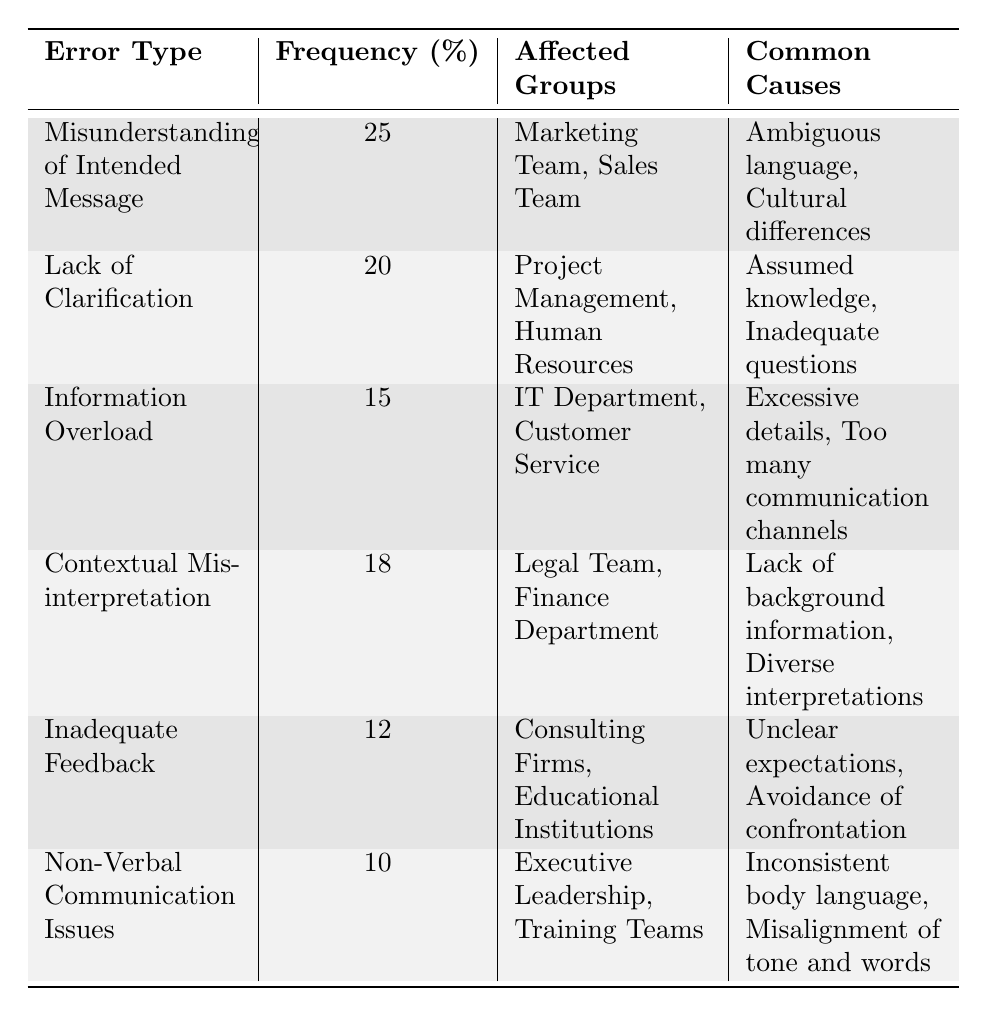What is the most common type of communication error? The table shows that the "Misunderstanding of Intended Message" has the highest frequency percentage at 25%.
Answer: Misunderstanding of Intended Message Which group is most affected by "Information Overload"? The table indicates that both the "IT Department" and "Customer Service" are affected by "Information Overload," but it does not specify which is more affected. Both teams are listed under the same error type.
Answer: IT Department and Customer Service What percentage of communication errors are categorized as "Inadequate Feedback"? The table provides a frequency percentage of 12% for "Inadequate Feedback."
Answer: 12% How many groups are affected by "Lack of Clarification"? The table lists "Project Management" and "Human Resources" as the two affected groups, indicating that there are two groups in total.
Answer: 2 What is the average frequency percentage of all types of communication errors listed? To find the average, we sum the percentages: 25 + 20 + 15 + 18 + 12 + 10 = 110%. There are six types of errors, so the average is 110/6 = 18.33%.
Answer: 18.33% Is "Contextual Misinterpretation" more frequent than "Non-Verbal Communication Issues"? Comparing the percentages, "Contextual Misinterpretation" has a frequency of 18%, while "Non-Verbal Communication Issues" has 10%. Since 18% is greater than 10%, the statement is true.
Answer: Yes What is the difference in frequency percentage between "Misunderstanding of Intended Message" and "Inadequate Feedback"? The frequency of "Misunderstanding of Intended Message" is 25%, and "Inadequate Feedback" is 12%. The difference is 25 - 12 = 13%.
Answer: 13% Which communication error has the lowest frequency, and what is its percentage? The table shows that "Non-Verbal Communication Issues" has the lowest frequency at 10%.
Answer: Non-Verbal Communication Issues, 10% What are the common causes of "Information Overload"? For "Information Overload," the common causes listed are "Excessive details" and "Too many communication channels."
Answer: Excessive details and Too many communication channels How many unique groups are affected across all communication errors? By counting each unique group: Marketing Team, Sales Team, Project Management, Human Resources, IT Department, Customer Service, Legal Team, Finance Department, Consulting Firms, Educational Institutions, Executive Leadership, and Training Teams, there are 12 unique groups in total.
Answer: 12 